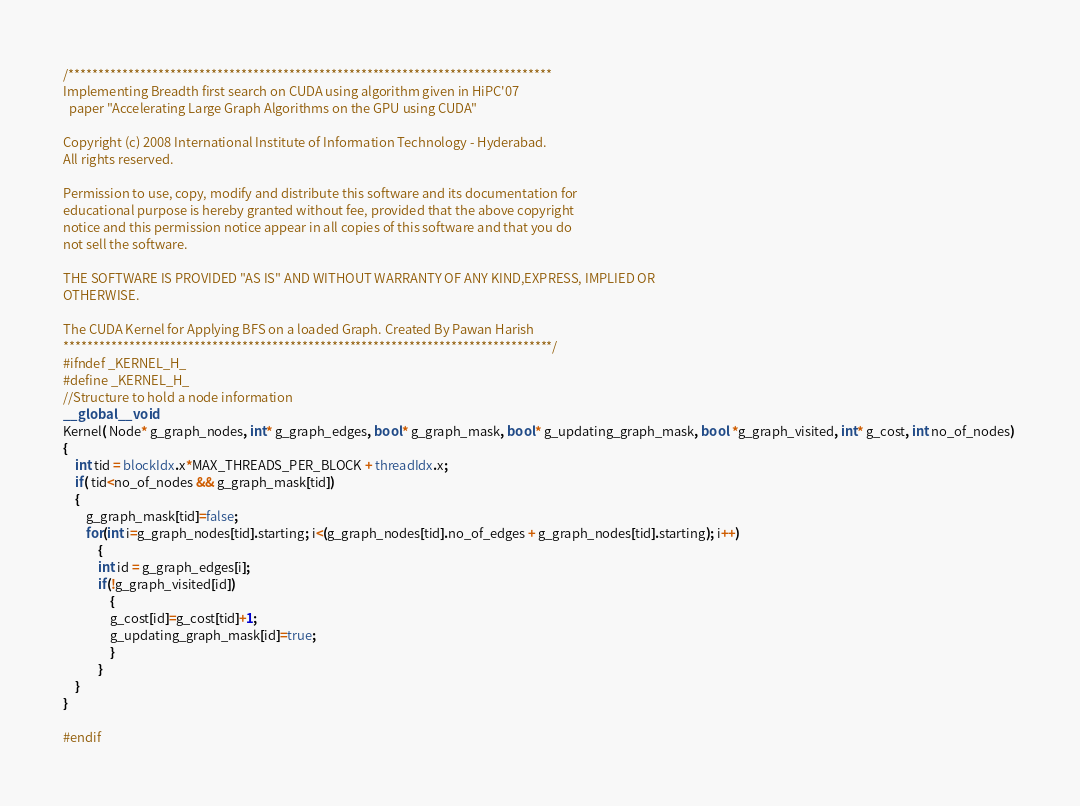<code> <loc_0><loc_0><loc_500><loc_500><_Cuda_>/*********************************************************************************
Implementing Breadth first search on CUDA using algorithm given in HiPC'07
  paper "Accelerating Large Graph Algorithms on the GPU using CUDA"

Copyright (c) 2008 International Institute of Information Technology - Hyderabad. 
All rights reserved.
  
Permission to use, copy, modify and distribute this software and its documentation for 
educational purpose is hereby granted without fee, provided that the above copyright 
notice and this permission notice appear in all copies of this software and that you do 
not sell the software.
  
THE SOFTWARE IS PROVIDED "AS IS" AND WITHOUT WARRANTY OF ANY KIND,EXPRESS, IMPLIED OR 
OTHERWISE.

The CUDA Kernel for Applying BFS on a loaded Graph. Created By Pawan Harish
**********************************************************************************/
#ifndef _KERNEL_H_
#define _KERNEL_H_
//Structure to hold a node information
__global__ void
Kernel( Node* g_graph_nodes, int* g_graph_edges, bool* g_graph_mask, bool* g_updating_graph_mask, bool *g_graph_visited, int* g_cost, int no_of_nodes) 
{
	int tid = blockIdx.x*MAX_THREADS_PER_BLOCK + threadIdx.x;
	if( tid<no_of_nodes && g_graph_mask[tid])
	{
		g_graph_mask[tid]=false;
		for(int i=g_graph_nodes[tid].starting; i<(g_graph_nodes[tid].no_of_edges + g_graph_nodes[tid].starting); i++)
			{
			int id = g_graph_edges[i];
			if(!g_graph_visited[id])
				{
				g_cost[id]=g_cost[tid]+1;
				g_updating_graph_mask[id]=true;
				}
			}
	}
}

#endif 
</code> 